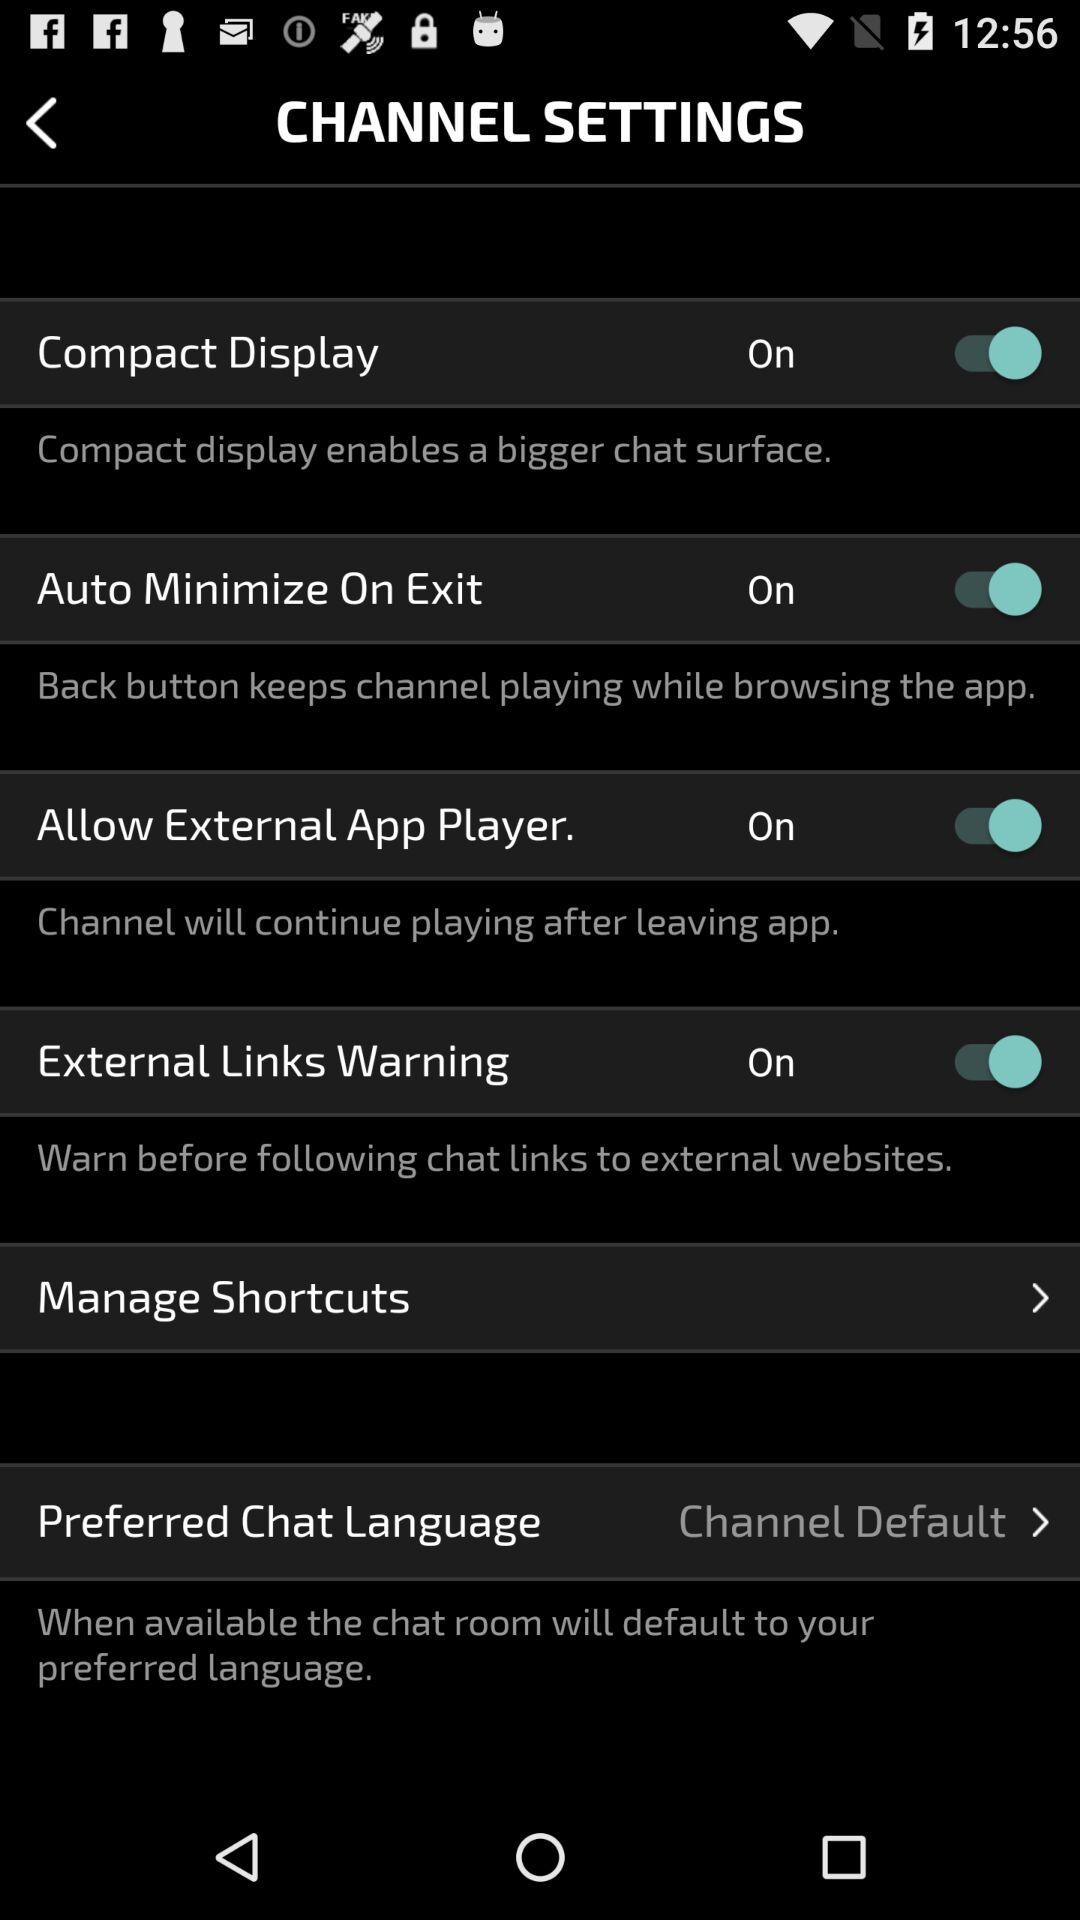What is the status of the "External Links Warning"? The status is "on". 